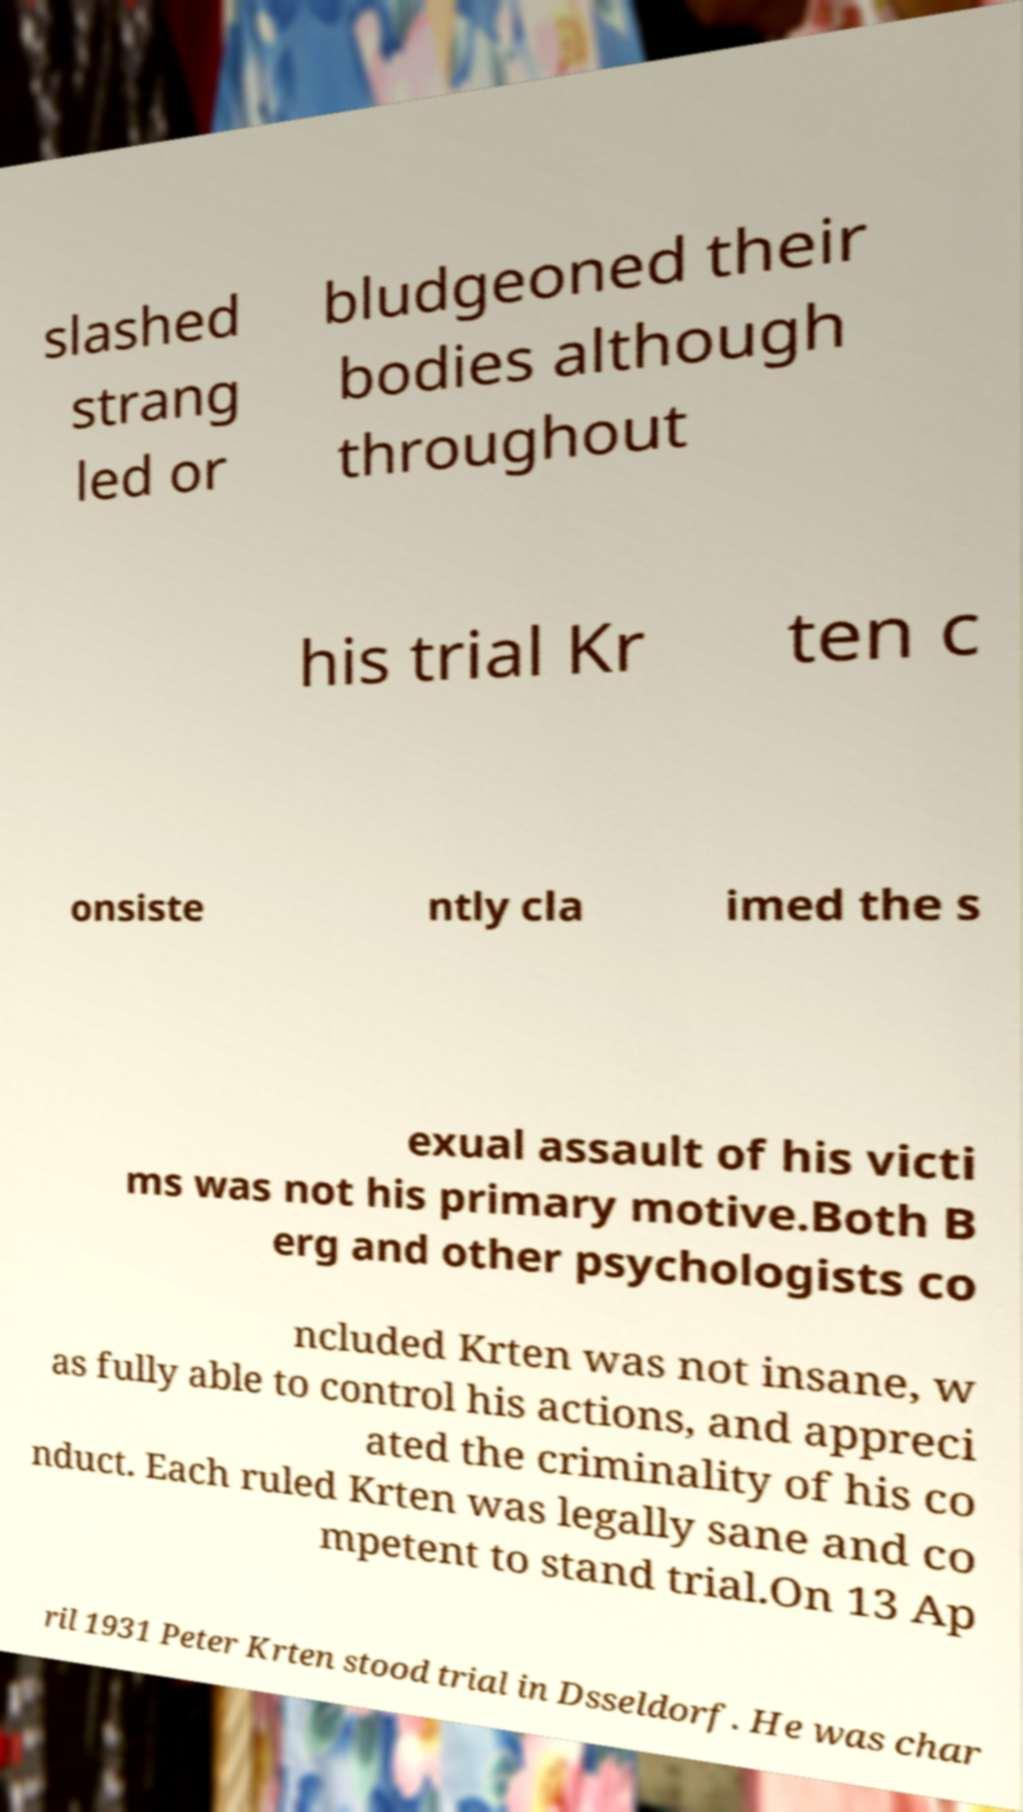Please identify and transcribe the text found in this image. slashed strang led or bludgeoned their bodies although throughout his trial Kr ten c onsiste ntly cla imed the s exual assault of his victi ms was not his primary motive.Both B erg and other psychologists co ncluded Krten was not insane, w as fully able to control his actions, and appreci ated the criminality of his co nduct. Each ruled Krten was legally sane and co mpetent to stand trial.On 13 Ap ril 1931 Peter Krten stood trial in Dsseldorf. He was char 